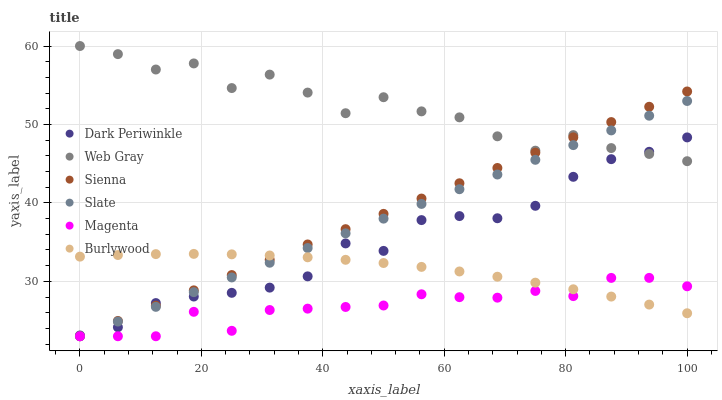Does Magenta have the minimum area under the curve?
Answer yes or no. Yes. Does Web Gray have the maximum area under the curve?
Answer yes or no. Yes. Does Burlywood have the minimum area under the curve?
Answer yes or no. No. Does Burlywood have the maximum area under the curve?
Answer yes or no. No. Is Sienna the smoothest?
Answer yes or no. Yes. Is Web Gray the roughest?
Answer yes or no. Yes. Is Burlywood the smoothest?
Answer yes or no. No. Is Burlywood the roughest?
Answer yes or no. No. Does Slate have the lowest value?
Answer yes or no. Yes. Does Burlywood have the lowest value?
Answer yes or no. No. Does Web Gray have the highest value?
Answer yes or no. Yes. Does Burlywood have the highest value?
Answer yes or no. No. Is Magenta less than Dark Periwinkle?
Answer yes or no. Yes. Is Web Gray greater than Burlywood?
Answer yes or no. Yes. Does Dark Periwinkle intersect Slate?
Answer yes or no. Yes. Is Dark Periwinkle less than Slate?
Answer yes or no. No. Is Dark Periwinkle greater than Slate?
Answer yes or no. No. Does Magenta intersect Dark Periwinkle?
Answer yes or no. No. 